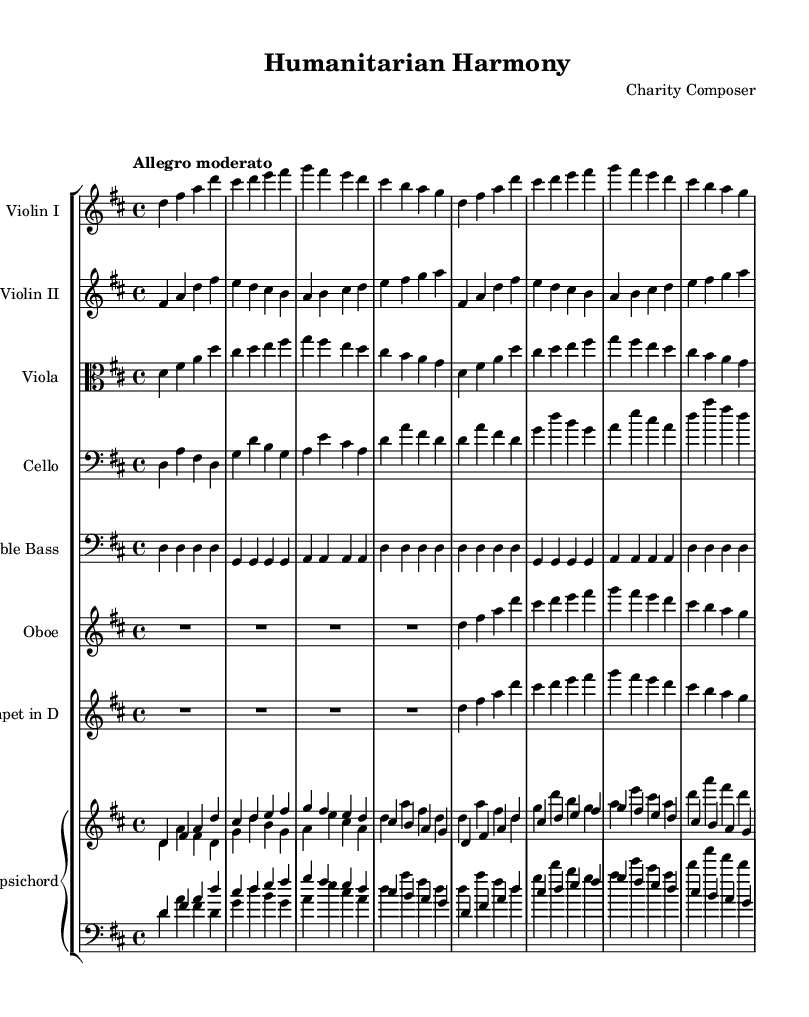What is the key signature of this music? The key signature is indicated by the sharps or flats at the beginning of the staff. In this piece, there are two sharps (F# and C#), which corresponds to the key of D major.
Answer: D major What is the time signature of this music? The time signature is found at the beginning of the piece, expressed as a fraction. Here, it is 4/4, which means there are four beats per measure.
Answer: 4/4 What is the tempo marking of this piece? The tempo marking is indicated below the title, showing the intended speed of the piece. This piece is marked "Allegro moderato," which suggests a cheerful, moderate speed.
Answer: Allegro moderato How many measures does the first violin part contain? By counting the groupings of vertical lines (bar lines) in the violin part, you can determine the number of measures. In this case, there are eight distinct measures in the first violin part.
Answer: 8 What is the instrumentation of this piece? The instrumentation is listed at the beginning of each staff and includes each instrument involved in the composition. This piece features two violins, a viola, a cello, a double bass, an oboe, a trumpet, and a harpsichord.
Answer: Two violins, viola, cello, double bass, oboe, trumpet, harpsichord What type of dynamics are indicated in the music? Dynamics in music usually appear as abbreviations like "p" for piano and "f" for forte, or other symbols. In this sheet, there are no explicit dynamics indicated, which suggests a uniform volume throughout, typical for some Baroque music.
Answer: No dynamics indicated How does the structure of this piece reflect typical Baroque composition? Baroque compositions often include a clear structure with multiple voices, characterized by counterpoint and harmony. Here, we have multiple instrumental lines that provide a rich texture and the interplay of melodies, a hallmark of the Baroque style.
Answer: Multiple voices and harmony 